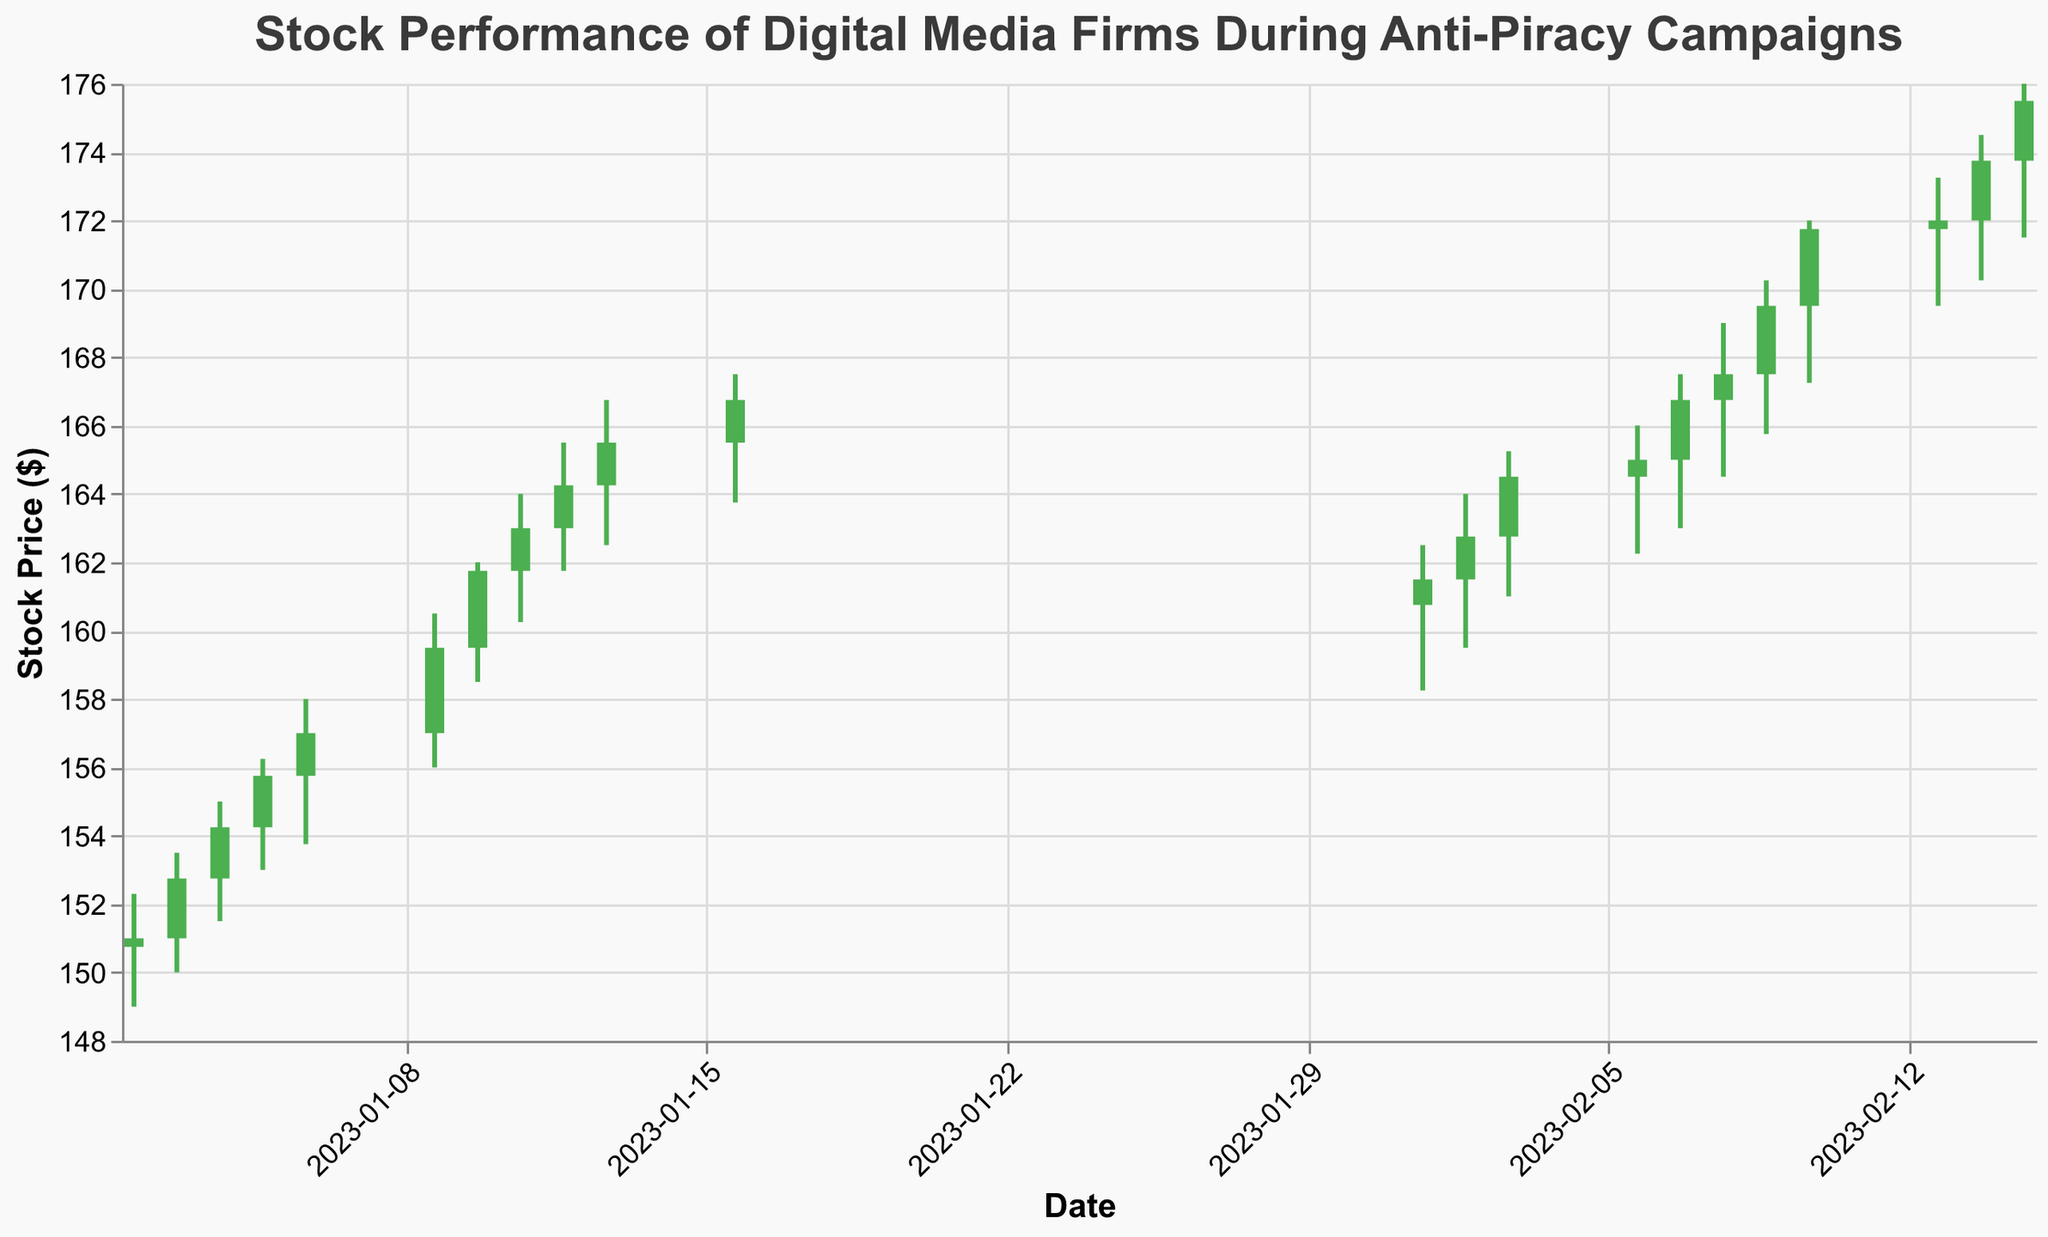What does the title of the chart indicate about the data? The title "Stock Performance of Digital Media Firms During Anti-Piracy Campaigns" suggests that the data represents the stock prices of digital media companies over time and the potential impact of anti-piracy efforts on these prices.
Answer: The chart shows stock performance during anti-piracy campaigns How many trading days are shown in the chart? By counting the number of distinct dates on the x-axis, we can see there are 20 trading days shown.
Answer: 20 Which date had the highest trading volume and what was it? The highest trading volume can be identified by looking at the volume values. The highest value is 1,950,000 on 2023-02-15.
Answer: 2023-02-15, 1,950,000 On which date did the stock price have the highest closing value? By examining the closing prices, the highest closing value is on 2023-02-15, with a closing price of $175.50.
Answer: 2023-02-15 What trend in stock price can be observed during the first week of trading in 2023? Observing the candlestick bars from 2023-01-02 to 2023-01-06, the stock price shows an upward trend starting from a close of $151.00 to a close of $157.00.
Answer: Upward trend During which date range was there a notable increase in both stock price and volume? Comparing the 'Close' and 'Volume' values between dates, a notable increase can be seen from 2023-01-09 to 2023-01-13, where the closing price rises from $159.50 to $165.50, and the volume increases from 1,500,000 to 1,700,000.
Answer: 2023-01-09 to 2023-01-13 How does the volume on 2023-02-10 compare with that on 2023-02-15? By comparing the volume values, the volume on 2023-02-10 is 1,800,000, which is lower than the volume on 2023-02-15, which is 1,950,000.
Answer: Lower What is the percentage increase in the closing price from 2023-01-02 to 2023-02-15? To find the percentage increase: ((175.50 - 151.00) / 151.00) * 100 = 16.24%.
Answer: 16.24% Which date had the lowest closing price and what was it? By looking at the closing prices, the lowest closing price is on 2023-01-02 at $151.00.
Answer: 2023-01-02, $151.00 What is the average closing price over the entire date range provided? Sum up all the closing prices and divide by the number of days: (151.00 + 152.75 + 154.25 + 155.75 + 157.00 + 159.50 + 161.75 + 163.00 + 164.25 + 165.50 + 166.75 + 161.50 + 162.75 + 164.50 + 165.00 + 166.75 + 167.50 + 169.50 + 171.75 + 172.00 + 173.75 + 175.00) / 22 ≈ 163.79
Answer: 163.79 